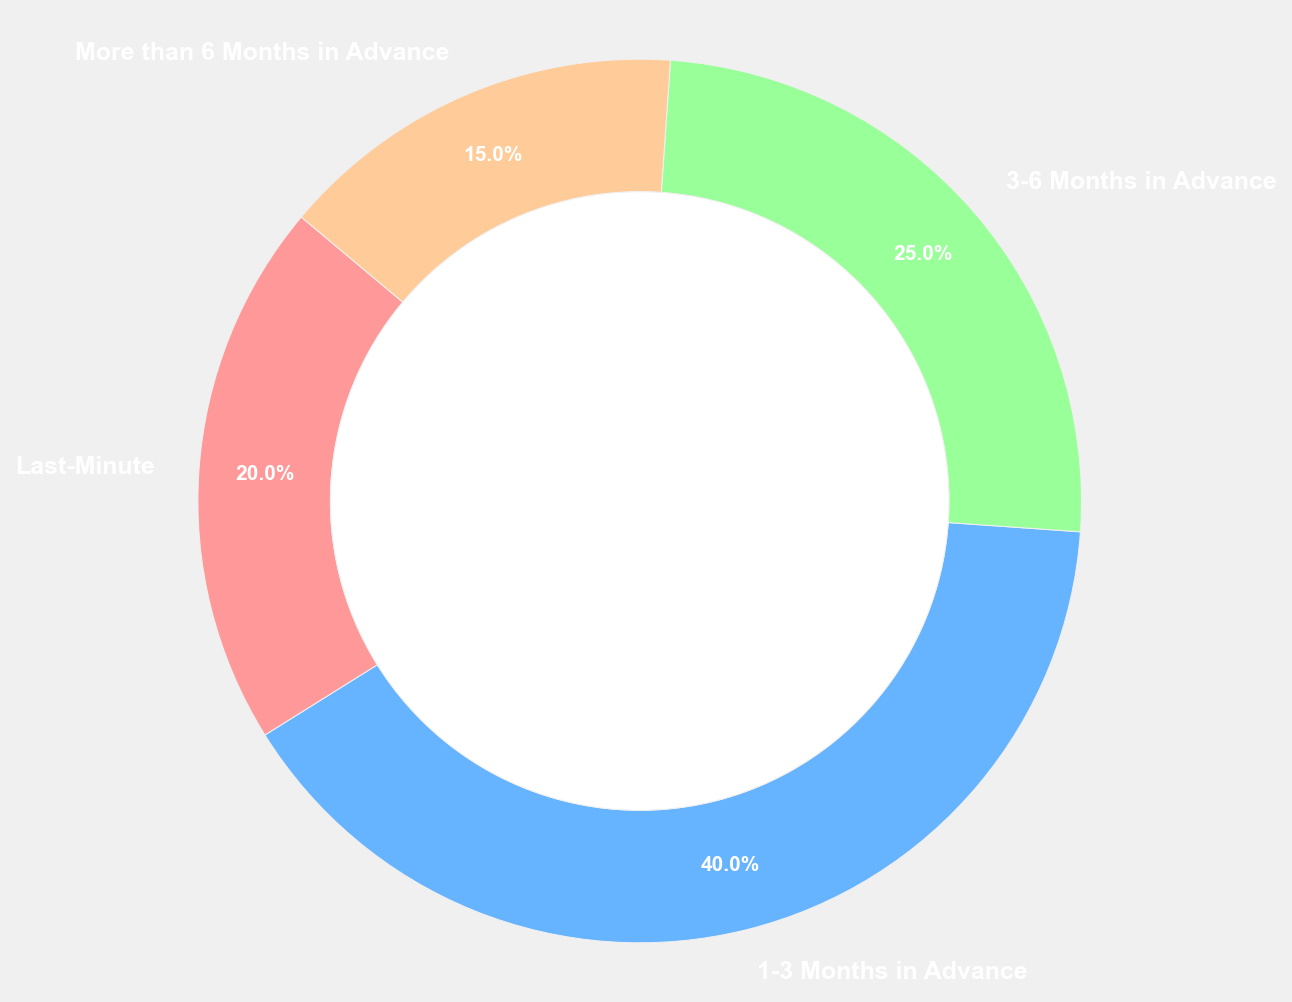What is the proportion of travelers booking 1-3 months in advance compared to those booking last-minute? The chart shows 40% of travelers book 1-3 months in advance, while 20% of travelers book last-minute. The proportion of 1-3 months to last-minute is 40/20, which simplifies to 2. Therefore, travelers booking 1-3 months in advance is twice as many as those booking last-minute.
Answer: 2 Which booking timeframe has the least percentage of travelers? From the chart, the segment labeled "More than 6 Months in Advance" represents 15%, which is the smallest percentage among all the timeframes.
Answer: More than 6 Months in Advance What is the combined percentage of travelers who book more than 3 months in advance? The chart shows "3-6 Months in Advance" with 25% and "More than 6 Months in Advance" with 15%. Adding these together, 25% + 15% = 40%.
Answer: 40% How does the percentage of travelers booking 3-6 months in advance compare to those booking 1-3 months in advance? The percentage for "3-6 Months in Advance" is 25%, while for "1-3 Months in Advance" it is 40%. 25% is 15 percentage points less than 40%.
Answer: 15 percentage points less What is the average percentage of travelers across all booking timeframes? The percentages are 20%, 40%, 25%, and 15%. To find the average, add these percentages: 20 + 40 + 25 + 15 = 100, then divide by the number of booking categories, which is 4. Therefore, the average is 100 / 4 = 25%.
Answer: 25% Which timeframe has a larger proportion of travelers, "Last-Minute" or "More than 6 Months in Advance"? "Last-Minute" has 20%, while "More than 6 Months in Advance" has 15%. Comparing these, "Last-Minute" is larger.
Answer: Last-Minute If the total number of travelers is 1,000, how many book their travel last-minute? Given that 20% of travelers book last-minute, we multiply 1,000 travelers by 20%: 1,000 * 0.20 = 200 travelers.
Answer: 200 What is the ratio of travelers booking 3-6 months in advance to those booking last-minute? The percentage for "3-6 Months in Advance" is 25%, and "Last-Minute" is 20%. The ratio is 25/20, which simplifies to 5:4.
Answer: 5:4 